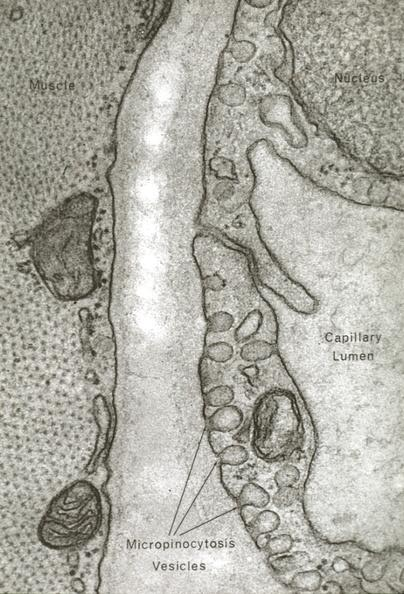where is this mage from?
Answer the question using a single word or phrase. Capillary 